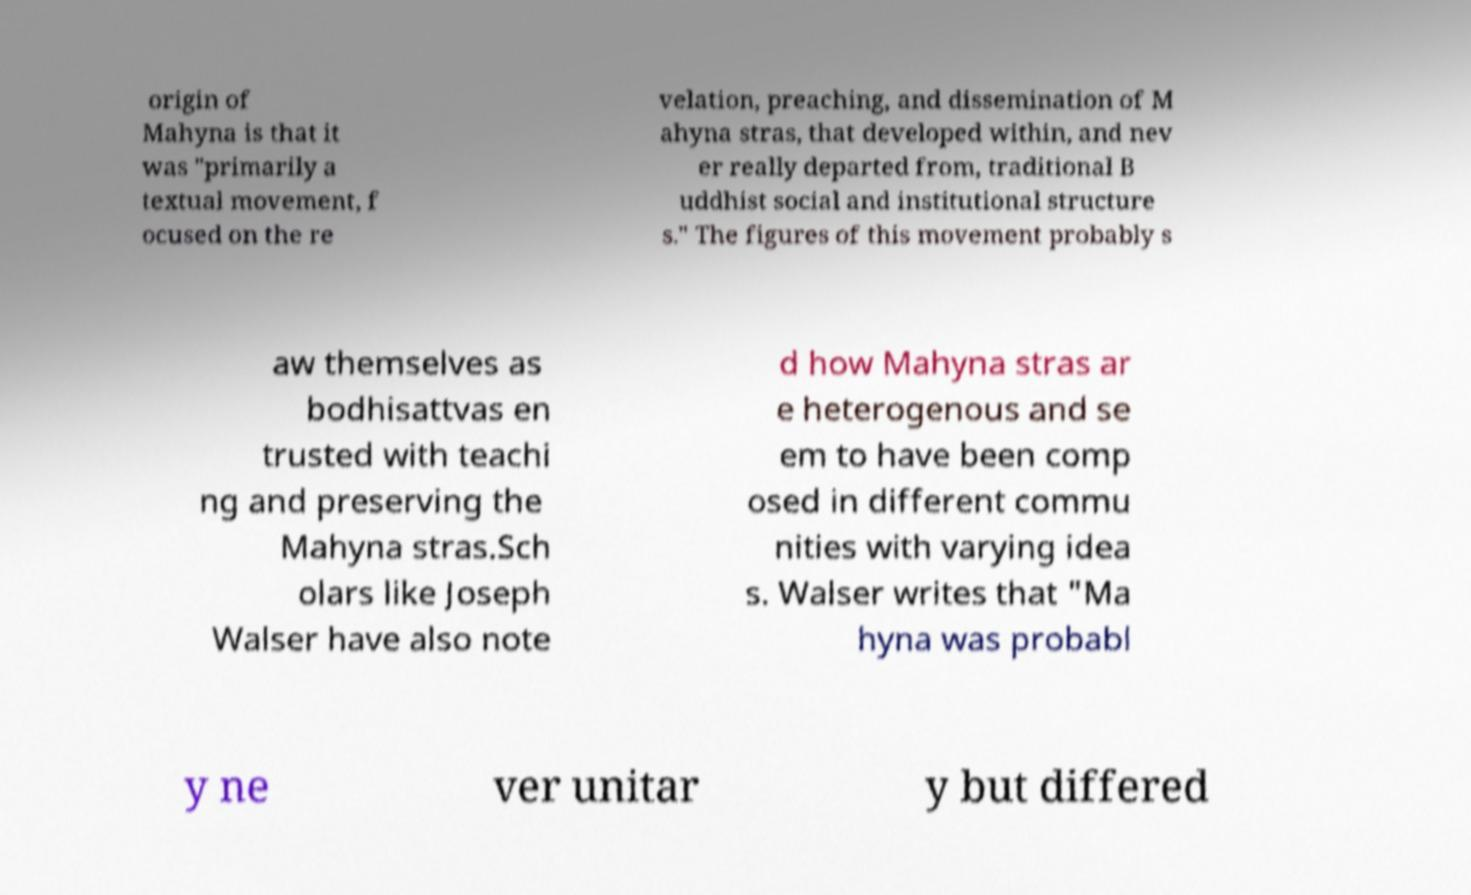Could you assist in decoding the text presented in this image and type it out clearly? origin of Mahyna is that it was "primarily a textual movement, f ocused on the re velation, preaching, and dissemination of M ahyna stras, that developed within, and nev er really departed from, traditional B uddhist social and institutional structure s." The figures of this movement probably s aw themselves as bodhisattvas en trusted with teachi ng and preserving the Mahyna stras.Sch olars like Joseph Walser have also note d how Mahyna stras ar e heterogenous and se em to have been comp osed in different commu nities with varying idea s. Walser writes that "Ma hyna was probabl y ne ver unitar y but differed 